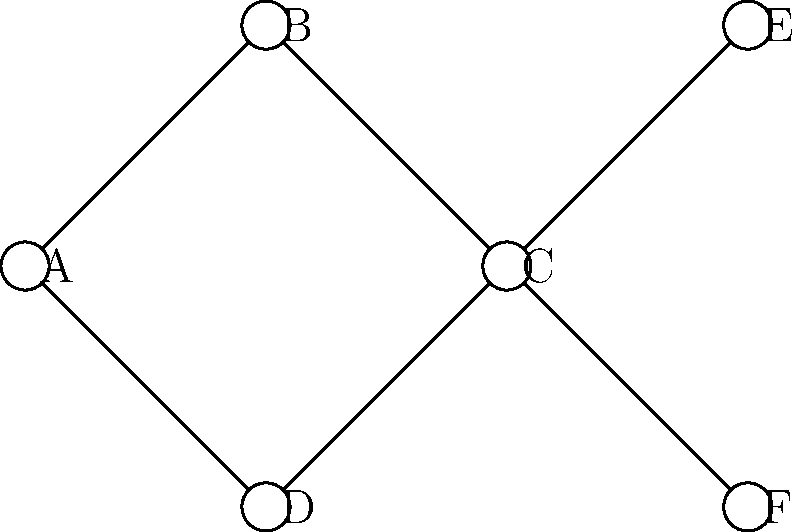As a Student Union leader analyzing student organization connections, you've created a network graph representing different student groups. In this graph, nodes represent student organizations, and edges represent collaborations between them. What is the minimum number of organizations that need to be removed to completely disconnect organization A from organization E? To solve this problem, we need to find the minimum cut between nodes A and E. Let's approach this step-by-step:

1. Identify all possible paths from A to E:
   - Path 1: A → B → C → E
   - Path 2: A → D → C → E

2. Analyze the common points in these paths:
   - Both paths pass through node C

3. Determine the minimum cut:
   - Removing node C would disconnect all paths from A to E
   - Alternatively, we could remove nodes B and D, but this would require removing two nodes instead of one

4. Check if there are any other solutions:
   - Removing A or E would also disconnect them, but the question asks for the minimum number of organizations to remove

5. Conclude:
   - The minimum number of organizations to remove is 1, which is organization C

This analysis demonstrates the concept of network centrality in topological data analysis, highlighting how certain nodes can be critical in maintaining connectivity within a network.
Answer: 1 